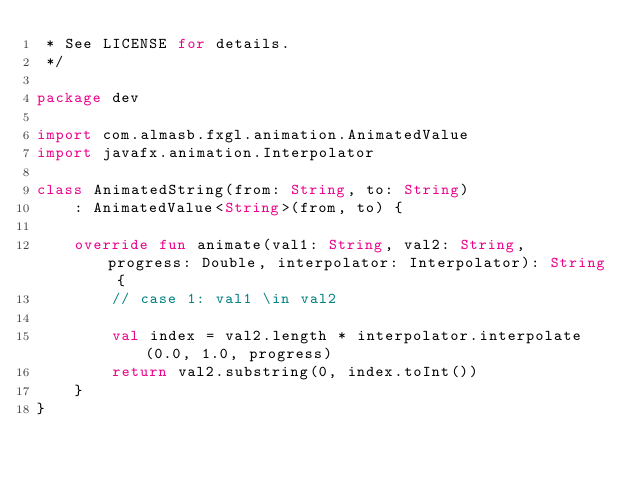Convert code to text. <code><loc_0><loc_0><loc_500><loc_500><_Kotlin_> * See LICENSE for details.
 */

package dev

import com.almasb.fxgl.animation.AnimatedValue
import javafx.animation.Interpolator

class AnimatedString(from: String, to: String)
    : AnimatedValue<String>(from, to) {

    override fun animate(val1: String, val2: String, progress: Double, interpolator: Interpolator): String {
        // case 1: val1 \in val2

        val index = val2.length * interpolator.interpolate(0.0, 1.0, progress)
        return val2.substring(0, index.toInt())
    }
}</code> 